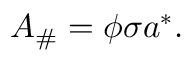Convert formula to latex. <formula><loc_0><loc_0><loc_500><loc_500>A _ { \# } = \phi \sigma a ^ { * } .</formula> 